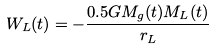Convert formula to latex. <formula><loc_0><loc_0><loc_500><loc_500>W _ { L } ( t ) = - \frac { 0 . 5 G M _ { g } ( t ) M _ { L } ( t ) } { r _ { L } }</formula> 